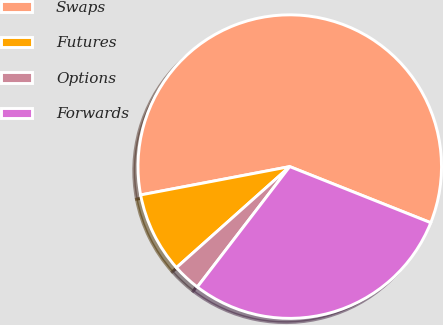Convert chart. <chart><loc_0><loc_0><loc_500><loc_500><pie_chart><fcel>Swaps<fcel>Futures<fcel>Options<fcel>Forwards<nl><fcel>59.02%<fcel>8.6%<fcel>2.99%<fcel>29.39%<nl></chart> 